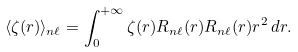Convert formula to latex. <formula><loc_0><loc_0><loc_500><loc_500>\langle \zeta ( r ) \rangle _ { n \ell } = \int _ { 0 } ^ { + \infty } \zeta ( r ) R _ { n \ell } ( r ) R _ { n \ell } ( r ) r ^ { 2 } \, d r .</formula> 